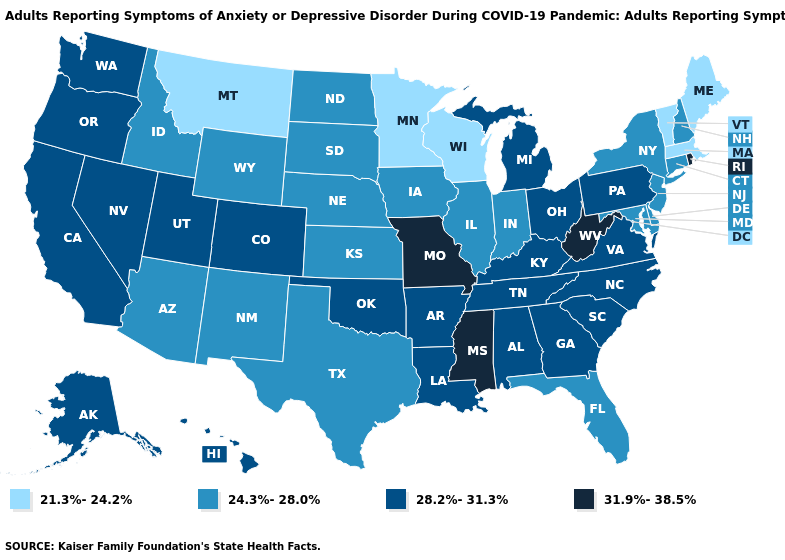What is the highest value in the Northeast ?
Give a very brief answer. 31.9%-38.5%. Does the map have missing data?
Concise answer only. No. Which states have the lowest value in the USA?
Quick response, please. Maine, Massachusetts, Minnesota, Montana, Vermont, Wisconsin. What is the value of Virginia?
Short answer required. 28.2%-31.3%. Does Wyoming have the lowest value in the USA?
Short answer required. No. Is the legend a continuous bar?
Keep it brief. No. Among the states that border Louisiana , does Mississippi have the lowest value?
Keep it brief. No. Name the states that have a value in the range 24.3%-28.0%?
Answer briefly. Arizona, Connecticut, Delaware, Florida, Idaho, Illinois, Indiana, Iowa, Kansas, Maryland, Nebraska, New Hampshire, New Jersey, New Mexico, New York, North Dakota, South Dakota, Texas, Wyoming. What is the value of North Dakota?
Quick response, please. 24.3%-28.0%. What is the value of Oklahoma?
Answer briefly. 28.2%-31.3%. Does Rhode Island have the highest value in the Northeast?
Quick response, please. Yes. Name the states that have a value in the range 24.3%-28.0%?
Write a very short answer. Arizona, Connecticut, Delaware, Florida, Idaho, Illinois, Indiana, Iowa, Kansas, Maryland, Nebraska, New Hampshire, New Jersey, New Mexico, New York, North Dakota, South Dakota, Texas, Wyoming. Name the states that have a value in the range 28.2%-31.3%?
Be succinct. Alabama, Alaska, Arkansas, California, Colorado, Georgia, Hawaii, Kentucky, Louisiana, Michigan, Nevada, North Carolina, Ohio, Oklahoma, Oregon, Pennsylvania, South Carolina, Tennessee, Utah, Virginia, Washington. Name the states that have a value in the range 31.9%-38.5%?
Be succinct. Mississippi, Missouri, Rhode Island, West Virginia. Name the states that have a value in the range 28.2%-31.3%?
Quick response, please. Alabama, Alaska, Arkansas, California, Colorado, Georgia, Hawaii, Kentucky, Louisiana, Michigan, Nevada, North Carolina, Ohio, Oklahoma, Oregon, Pennsylvania, South Carolina, Tennessee, Utah, Virginia, Washington. 